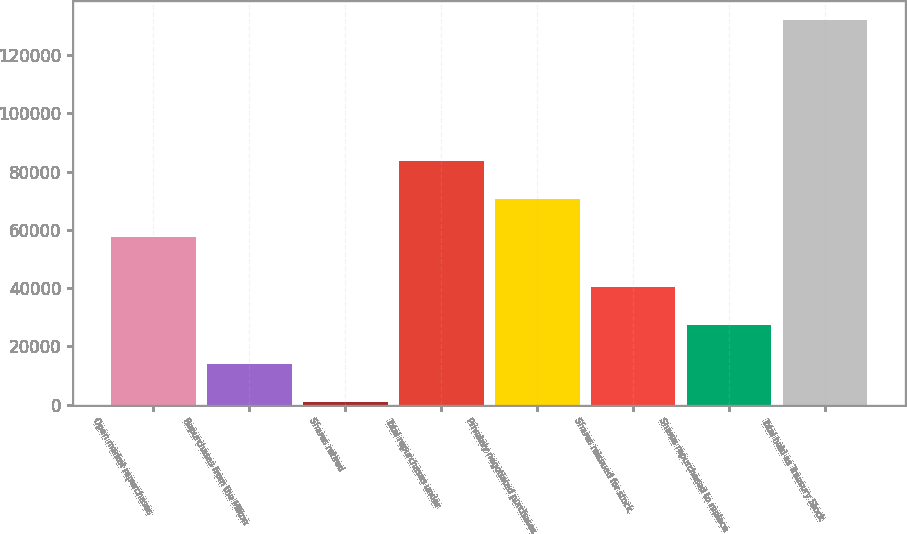Convert chart to OTSL. <chart><loc_0><loc_0><loc_500><loc_500><bar_chart><fcel>Open market repurchases<fcel>Repurchases from the Milton<fcel>Shares retired<fcel>Total repurchases under<fcel>Privately negotiated purchases<fcel>Shares reissued for stock<fcel>Shares repurchased to replace<fcel>Total held as Treasury Stock<nl><fcel>57436<fcel>14140.8<fcel>1056<fcel>83605.6<fcel>70520.8<fcel>40310.4<fcel>27225.6<fcel>131904<nl></chart> 